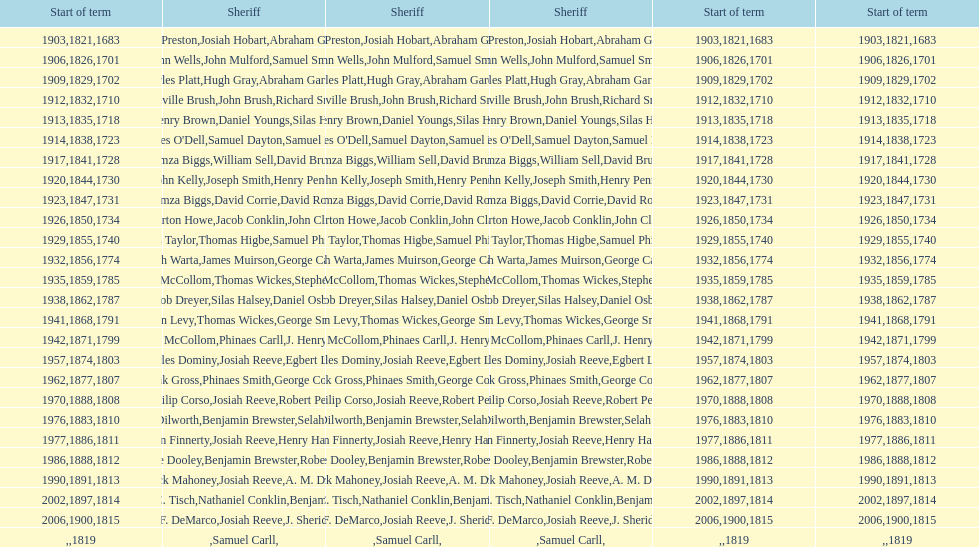How many sheriffs, in total, have there been in suffolk county? 76. 